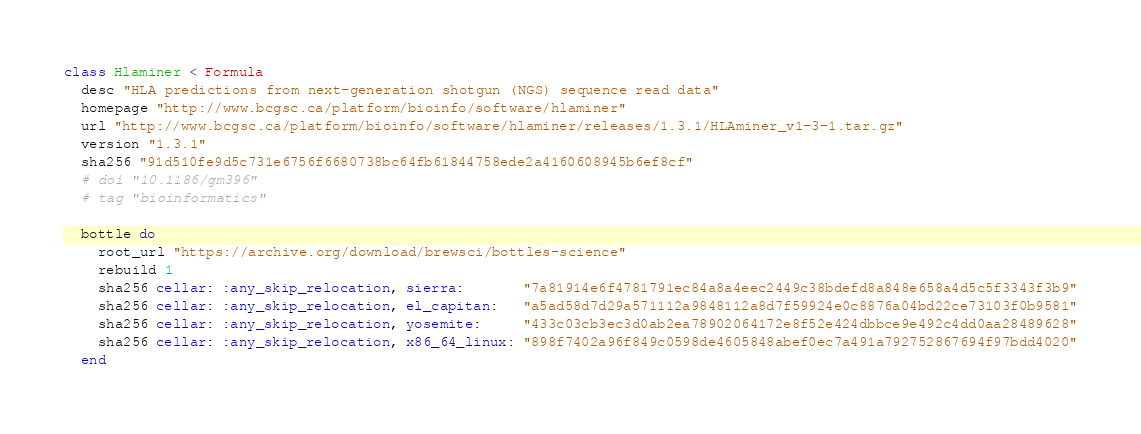<code> <loc_0><loc_0><loc_500><loc_500><_Ruby_>class Hlaminer < Formula
  desc "HLA predictions from next-generation shotgun (NGS) sequence read data"
  homepage "http://www.bcgsc.ca/platform/bioinfo/software/hlaminer"
  url "http://www.bcgsc.ca/platform/bioinfo/software/hlaminer/releases/1.3.1/HLAminer_v1-3-1.tar.gz"
  version "1.3.1"
  sha256 "91d510fe9d5c731e6756f6680738bc64fb61844758ede2a4160608945b6ef8cf"
  # doi "10.1186/gm396"
  # tag "bioinformatics"

  bottle do
    root_url "https://archive.org/download/brewsci/bottles-science"
    rebuild 1
    sha256 cellar: :any_skip_relocation, sierra:       "7a81914e6f4781791ec84a8a4eec2449c38bdefd8a848e658a4d5c5f3343f3b9"
    sha256 cellar: :any_skip_relocation, el_capitan:   "a5ad58d7d29a571112a9848112a8d7f59924e0c8876a04bd22ce73103f0b9581"
    sha256 cellar: :any_skip_relocation, yosemite:     "433c03cb3ec3d0ab2ea78902064172e8f52e424dbbce9e492c4dd0aa28489628"
    sha256 cellar: :any_skip_relocation, x86_64_linux: "898f7402a96f849c0598de4605848abef0ec7a491a792752867694f97bdd4020"
  end
</code> 